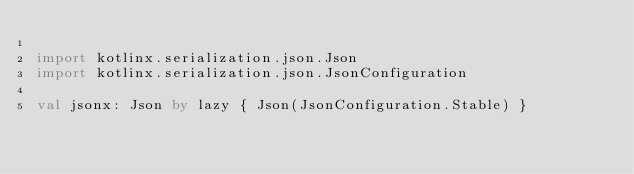<code> <loc_0><loc_0><loc_500><loc_500><_Kotlin_>
import kotlinx.serialization.json.Json
import kotlinx.serialization.json.JsonConfiguration

val jsonx: Json by lazy { Json(JsonConfiguration.Stable) }
</code> 